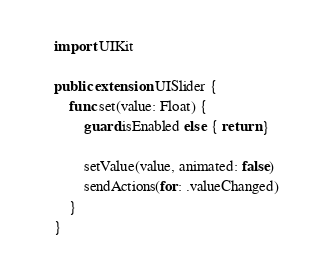<code> <loc_0><loc_0><loc_500><loc_500><_Swift_>import UIKit

public extension UISlider {
    func set(value: Float) {
        guard isEnabled else { return }

        setValue(value, animated: false)
        sendActions(for: .valueChanged)
    }
}
</code> 